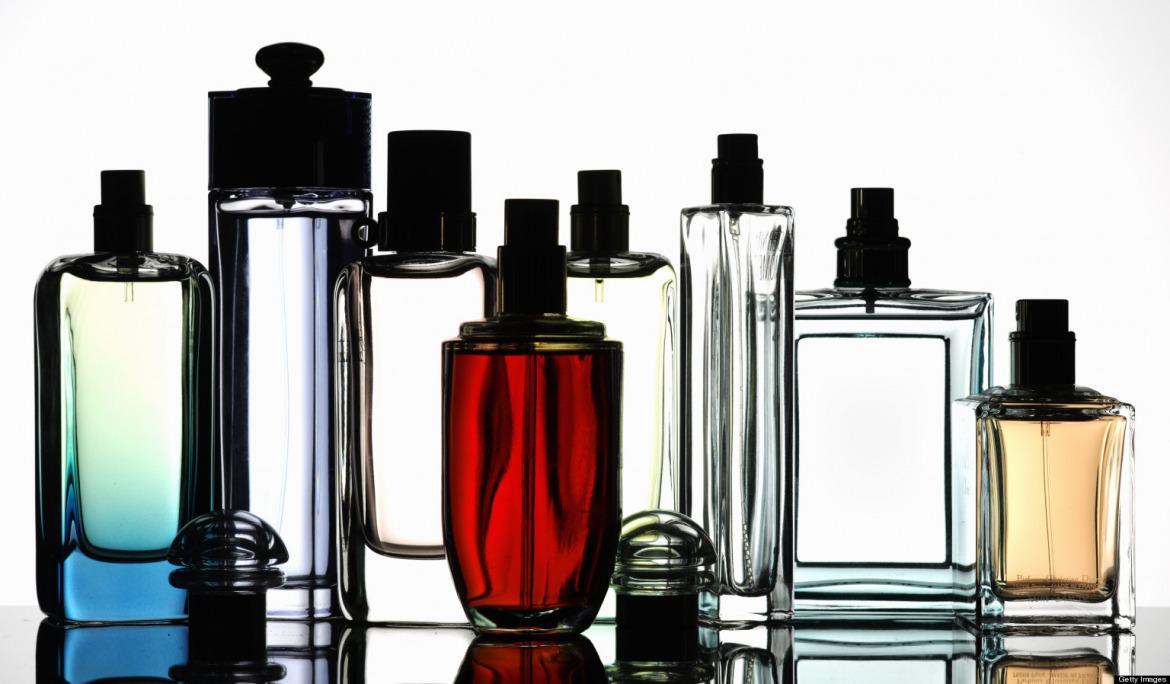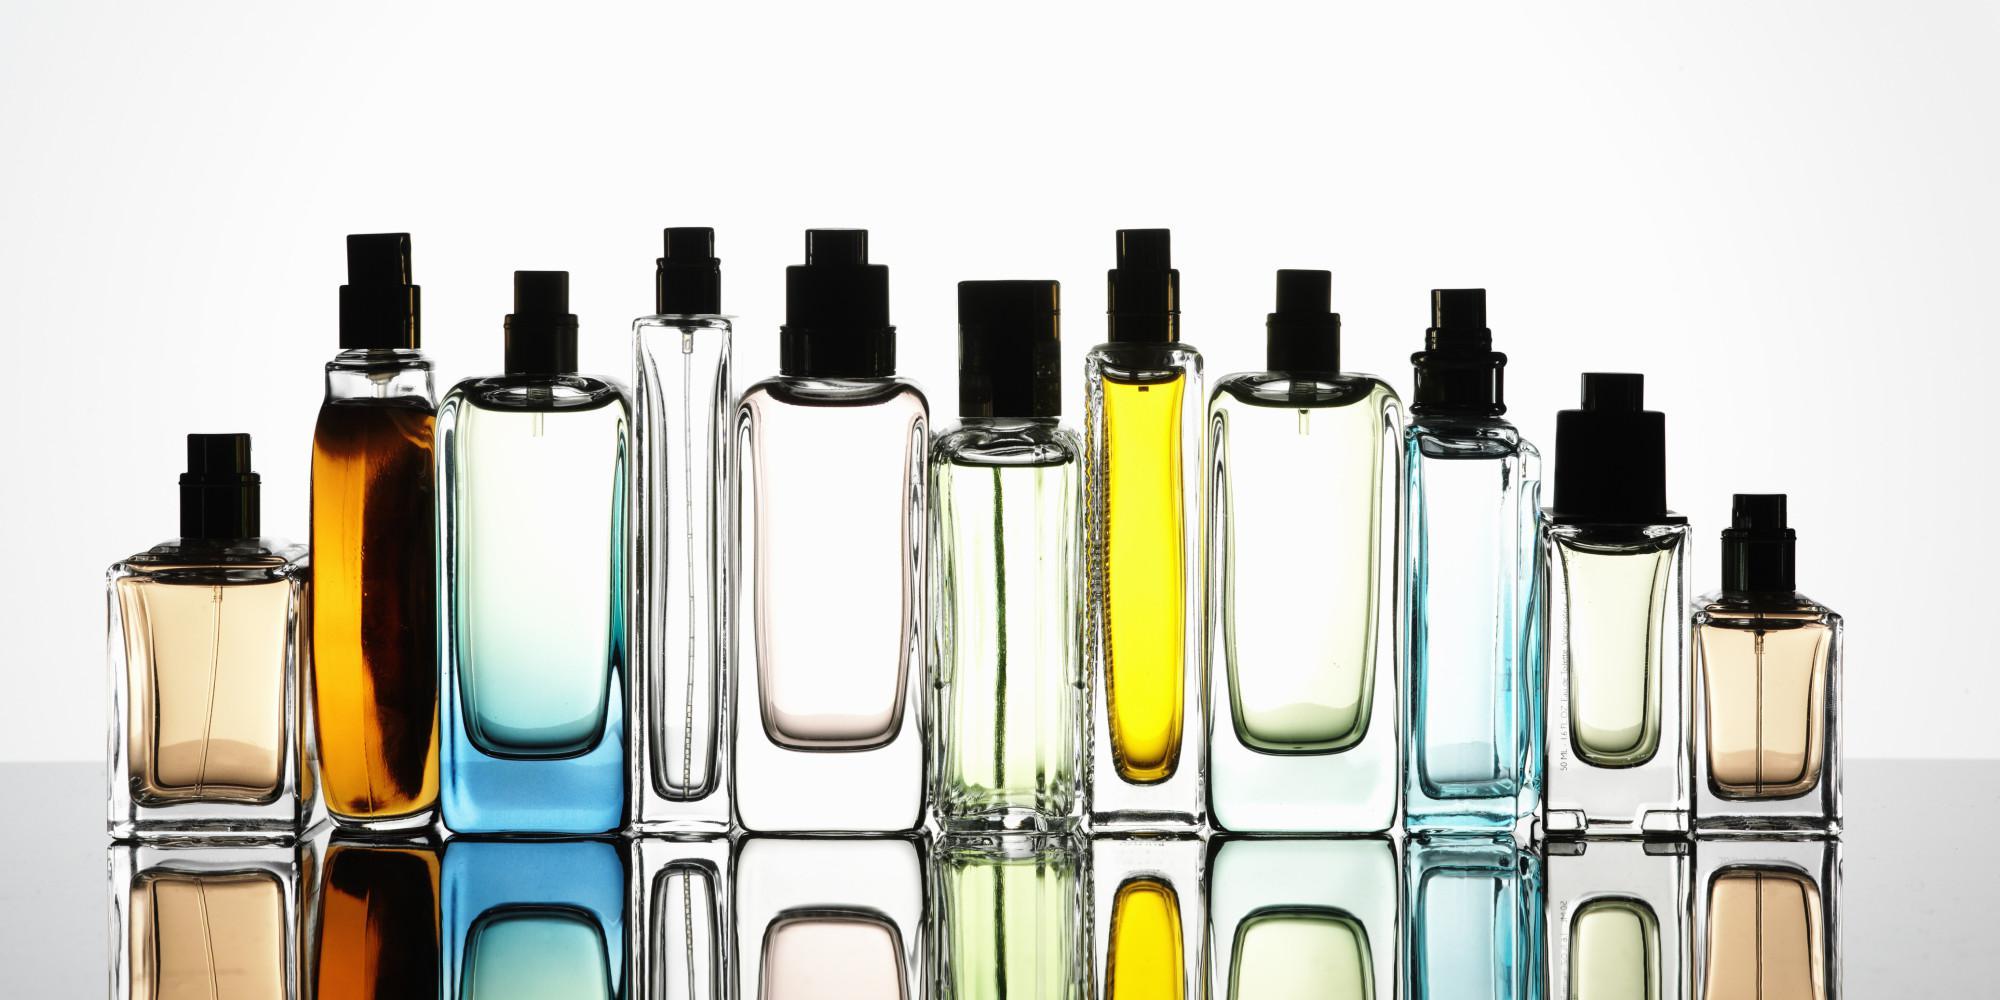The first image is the image on the left, the second image is the image on the right. Analyze the images presented: Is the assertion "There are 9 or more label-less perfume bottles." valid? Answer yes or no. Yes. The first image is the image on the left, the second image is the image on the right. For the images displayed, is the sentence "In both images the products are all of varying heights." factually correct? Answer yes or no. Yes. 